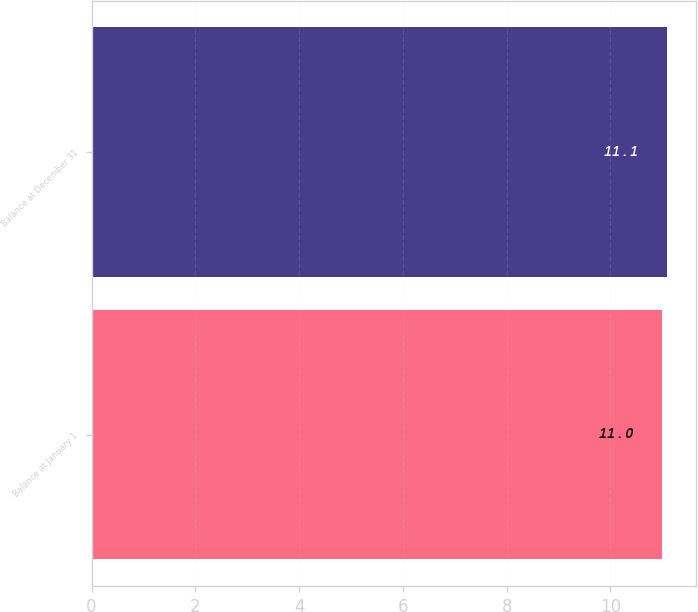Convert chart. <chart><loc_0><loc_0><loc_500><loc_500><bar_chart><fcel>Balance at January 1<fcel>Balance at December 31<nl><fcel>11<fcel>11.1<nl></chart> 